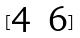<formula> <loc_0><loc_0><loc_500><loc_500>[ \begin{matrix} 4 & 6 \end{matrix} ]</formula> 